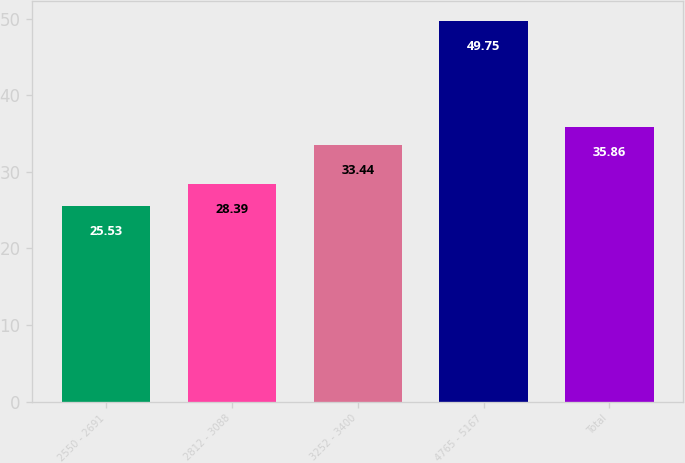Convert chart to OTSL. <chart><loc_0><loc_0><loc_500><loc_500><bar_chart><fcel>2550 - 2691<fcel>2812 - 3088<fcel>3252 - 3400<fcel>4765 - 5167<fcel>Total<nl><fcel>25.53<fcel>28.39<fcel>33.44<fcel>49.75<fcel>35.86<nl></chart> 